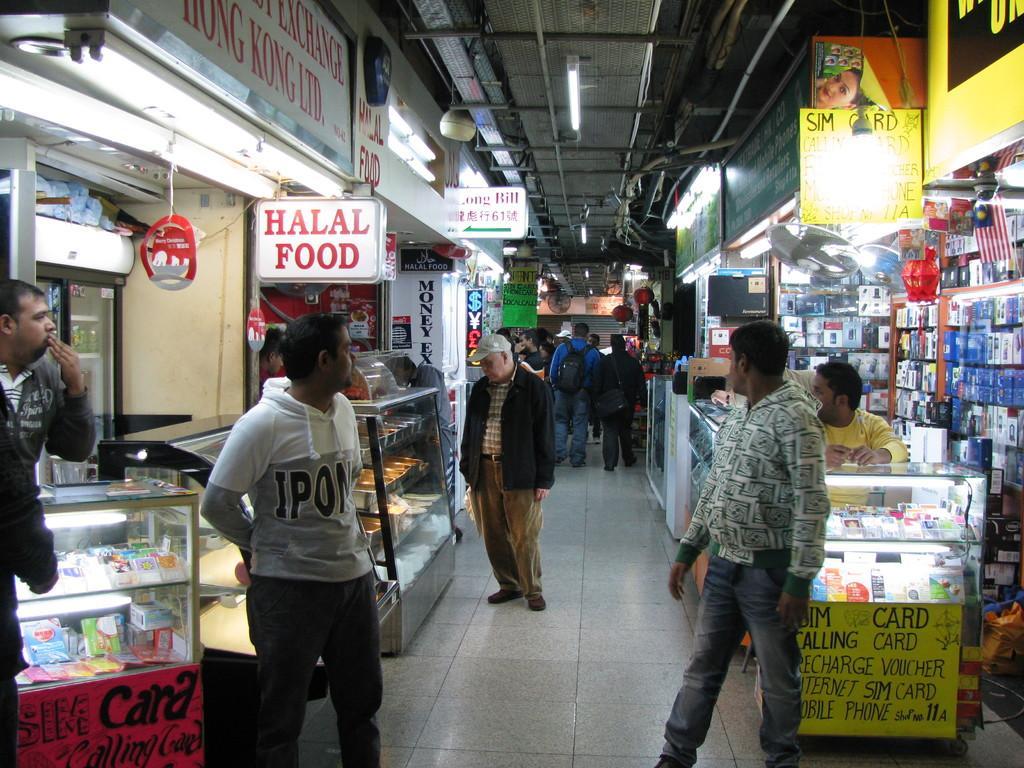Can you describe this image briefly? There are many people. Some are wearing bags and cap. On the sides there are shops. On the right side there are many items. Inside the shop there are name boards. Also there is a glass cupboard. Inside that there are many items. There is a fan. On the left side there are many glass cupboards. Inside that there are many items. There are name boards. On the ceiling there are lights. 